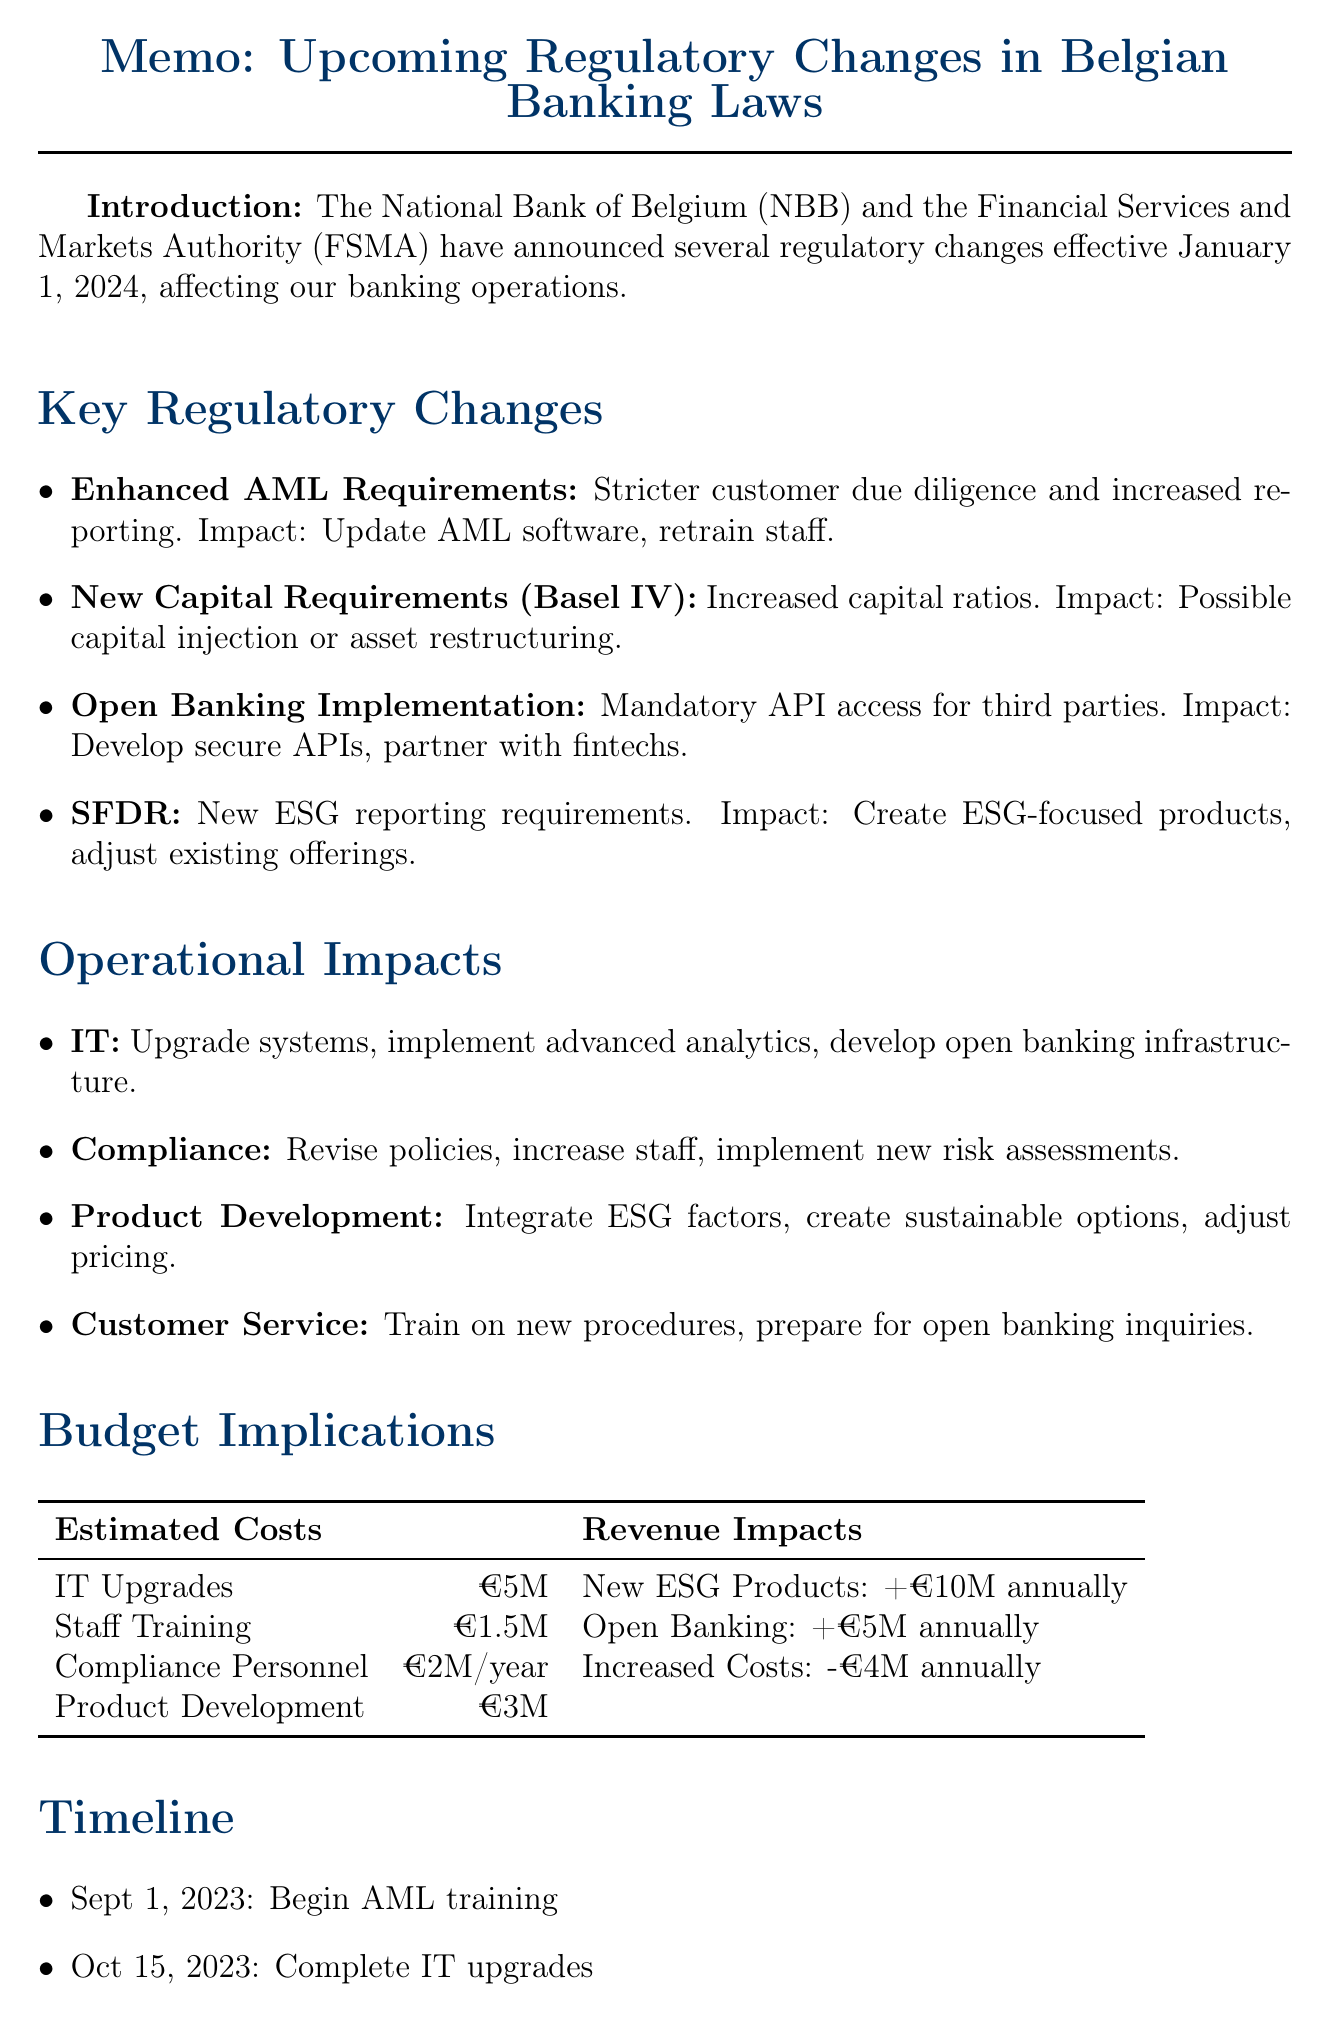What are the key regulatory changes? The memo outlines various regulatory changes, including Enhanced AML Requirements, New Capital Requirements under Basel IV, Open Banking Implementation, and Sustainable Finance Disclosure Regulation (SFDR).
Answer: Enhanced AML Requirements, New Capital Requirements under Basel IV, Open Banking Implementation, Sustainable Finance Disclosure Regulation (SFDR) When do the regulatory changes come into effect? The effective date for the changes is specified in the introduction of the memo.
Answer: January 1, 2024 What is the estimated cost for IT upgrades? The budget implications section provides the estimated costs for various changes, including IT upgrades.
Answer: €5 million What is one operational change for the Compliance department? The operational impacts section describes changes for different departments, including Compliance.
Answer: Revision of internal policies and procedures What is one potential revenue impact mentioned? The memo lists potential revenue impacts related to ESG products and open banking partnerships.
Answer: +€10 million annually What deadline is set for submitting action plans? The conclusion of the memo specifies a deadline for department heads to submit action plans.
Answer: August 1, 2023 What does the Open Banking Implementation require? The key regulatory changes section describes the requirements of Open Banking Implementation.
Answer: Mandatory API access for third-party providers What is the total estimated cost for staff training? The budget implications section lists the estimated costs for various changes, including staff training.
Answer: €1.5 million What action is scheduled for December 15, 2023? The timeline in the memo outlines actions and their scheduled dates, including the action for December 15.
Answer: Finalize open banking API implementation 